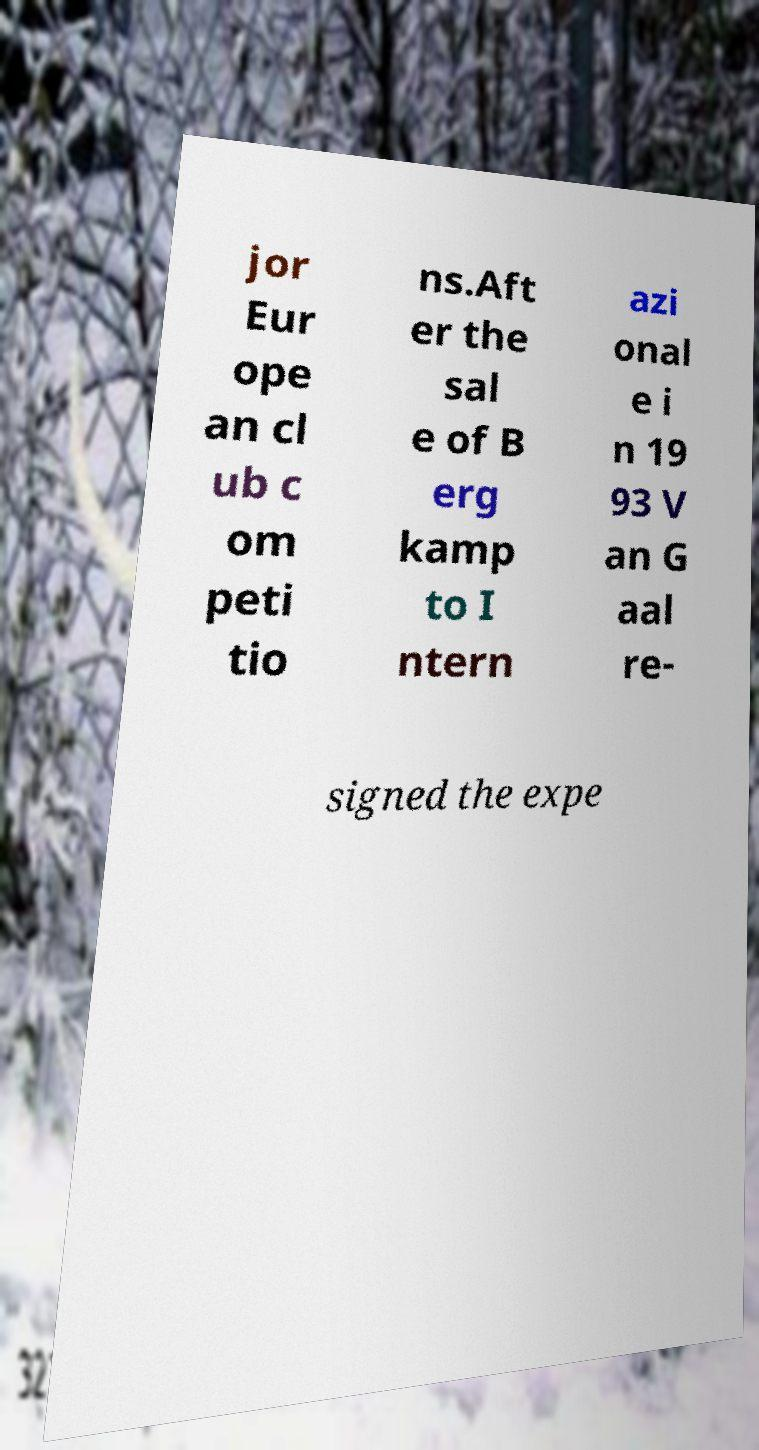Could you assist in decoding the text presented in this image and type it out clearly? jor Eur ope an cl ub c om peti tio ns.Aft er the sal e of B erg kamp to I ntern azi onal e i n 19 93 V an G aal re- signed the expe 